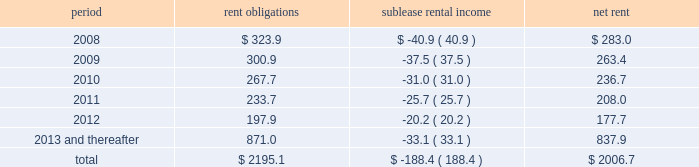Future minimum lease commitments for office premises and equipment under non-cancelable leases , along with minimum sublease rental income to be received under non-cancelable subleases , are as follows : period rent obligations sublease rental income net rent .
Guarantees we have certain contingent obligations under guarantees of certain of our subsidiaries ( 201cparent company guarantees 201d ) relating principally to credit facilities , guarantees of certain media payables and operating leases .
The amount of such parent company guarantees was $ 327.1 and $ 327.9 as of december 31 , 2007 and 2006 , respectively .
In the event of non-payment by the applicable subsidiary of the obligations covered by a guarantee , we would be obligated to pay the amounts covered by that guarantee .
As of december 31 , 2007 , there are no material assets pledged as security for such parent company guarantees .
Contingent acquisition obligations we have structured certain acquisitions with additional contingent purchase price obligations in order to reduce the potential risk associated with negative future performance of the acquired entity .
In addition , we have entered into agreements that may require us to purchase additional equity interests in certain consolidated and unconsolidated subsidiaries .
The amounts relating to these transactions are based on estimates of the future financial performance of the acquired entity , the timing of the exercise of these rights , changes in foreign currency exchange rates and other factors .
We have not recorded a liability for these items since the definitive amounts payable are not determinable or distributable .
When the contingent acquisition obligations have been met and consideration is determinable and distributable , we record the fair value of this consideration as an additional cost of the acquired entity .
However , we recognize deferred payments and purchases of additional interests after the effective date of purchase that are contingent upon the future employment of owners as compensation expense .
Compensation expense is determined based on the terms and conditions of the respective acquisition agreements and employment terms of the former owners of the acquired businesses .
This future expense will not be allocated to the assets and liabilities acquired and is amortized over the required employment terms of the former owners .
The following table details the estimated liability with respect to our contingent acquisition obligations and the estimated amount that would be paid under the options , in the event of exercise at the earliest exercise date .
All payments are contingent upon achieving projected operating performance targets and satisfying other notes to consolidated financial statements 2014 ( continued ) ( amounts in millions , except per share amounts ) .
What is the mathematical range for the range of rent obligations from 2008-2012? 
Computations: (323.9 - 197.9)
Answer: 126.0. 